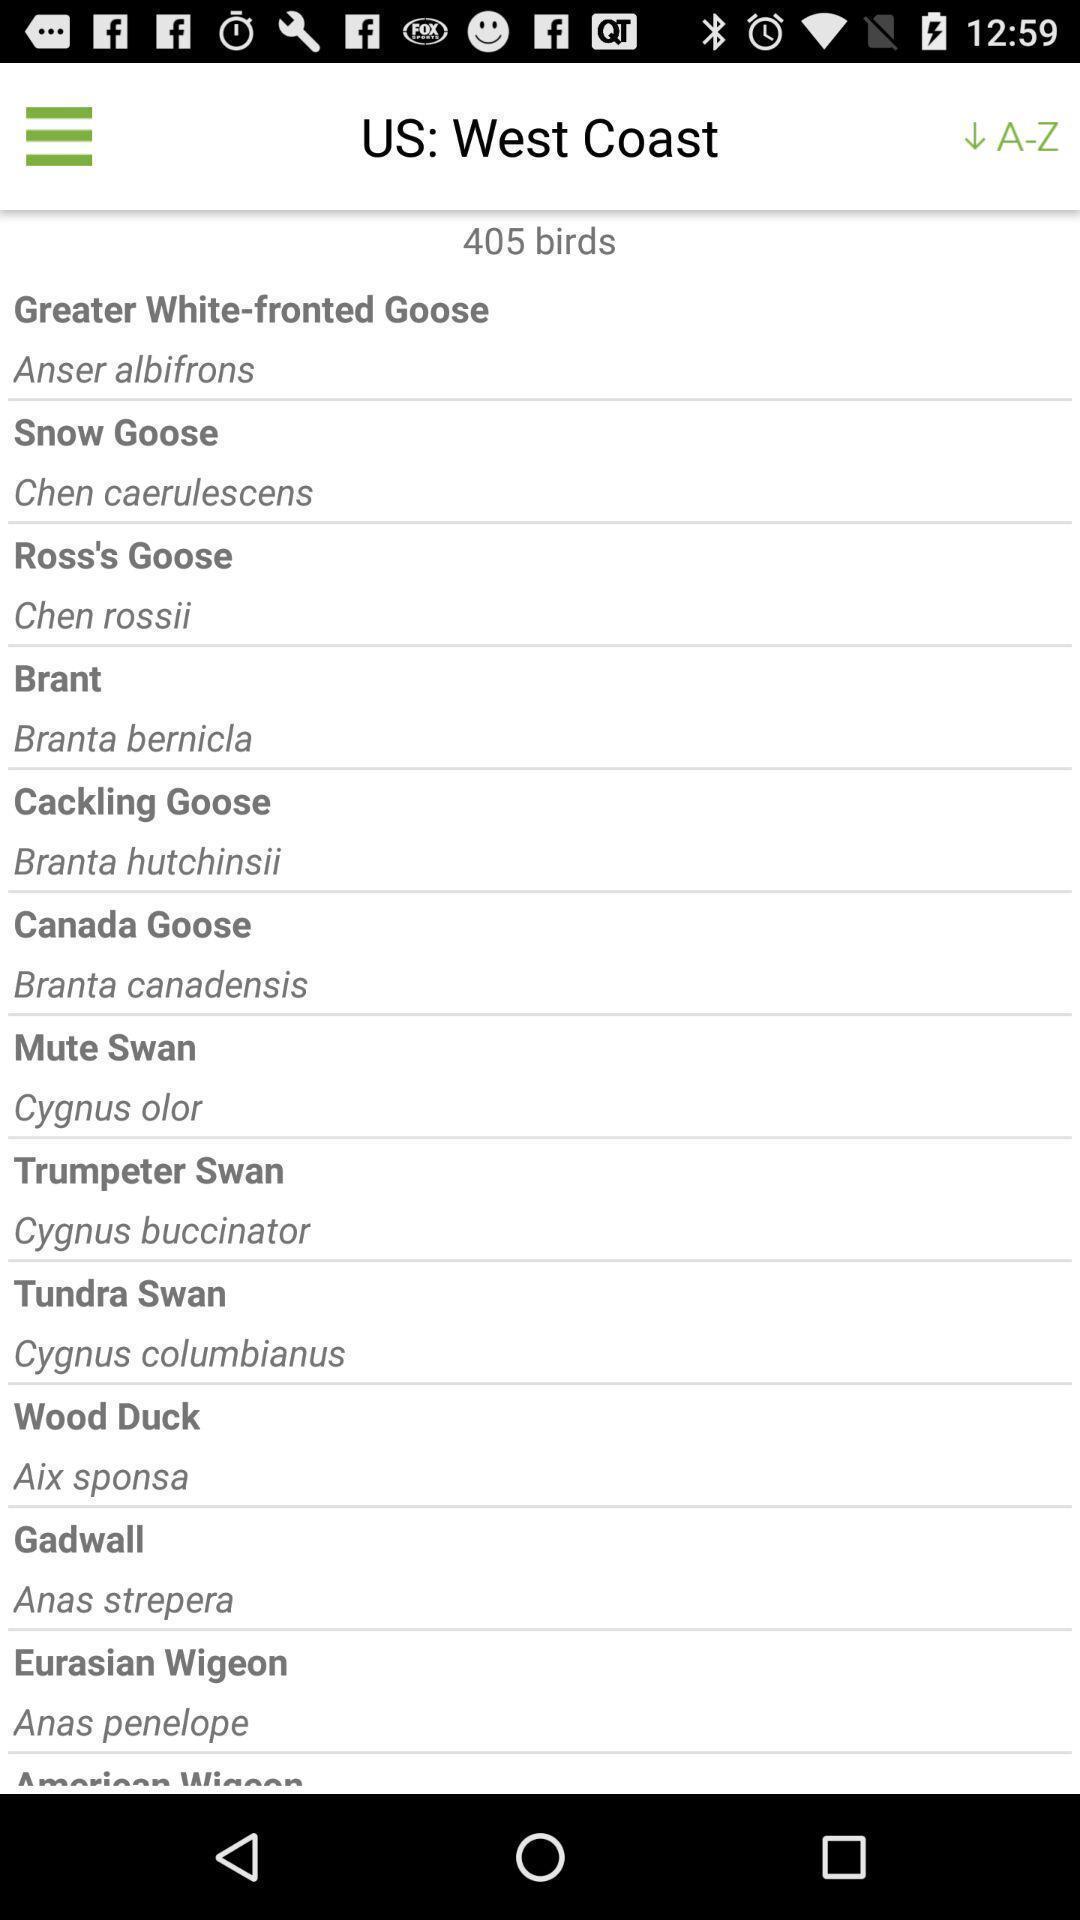Summarize the main components in this picture. Screen displaying a list of bird names. 